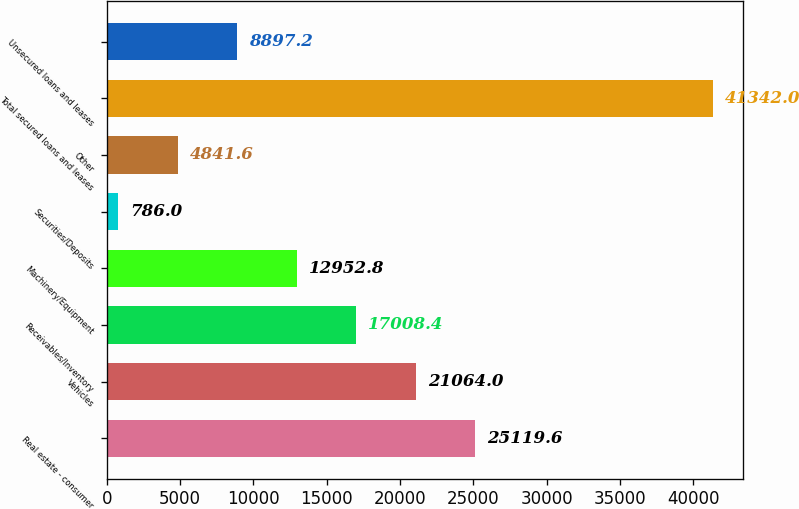<chart> <loc_0><loc_0><loc_500><loc_500><bar_chart><fcel>Real estate - consumer<fcel>Vehicles<fcel>Receivables/Inventory<fcel>Machinery/Equipment<fcel>Securities/Deposits<fcel>Other<fcel>Total secured loans and leases<fcel>Unsecured loans and leases<nl><fcel>25119.6<fcel>21064<fcel>17008.4<fcel>12952.8<fcel>786<fcel>4841.6<fcel>41342<fcel>8897.2<nl></chart> 